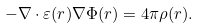<formula> <loc_0><loc_0><loc_500><loc_500>- \nabla \cdot \varepsilon ( r ) \nabla \Phi ( r ) = 4 \pi \rho ( r ) .</formula> 